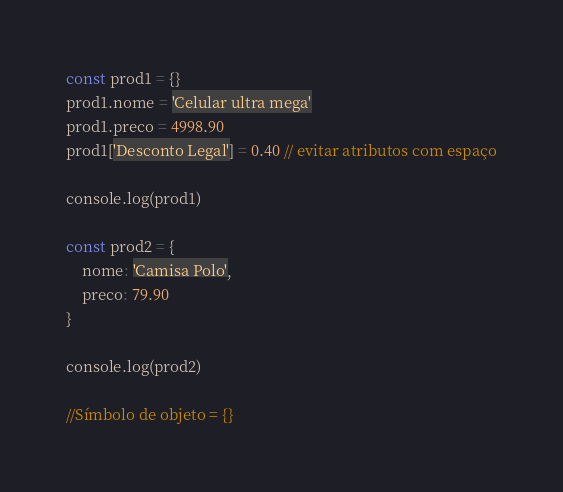<code> <loc_0><loc_0><loc_500><loc_500><_JavaScript_>const prod1 = {}
prod1.nome = 'Celular ultra mega'
prod1.preco = 4998.90
prod1['Desconto Legal'] = 0.40 // evitar atributos com espaço

console.log(prod1)

const prod2 = {
    nome: 'Camisa Polo',
    preco: 79.90
}

console.log(prod2)

//Símbolo de objeto = {}</code> 